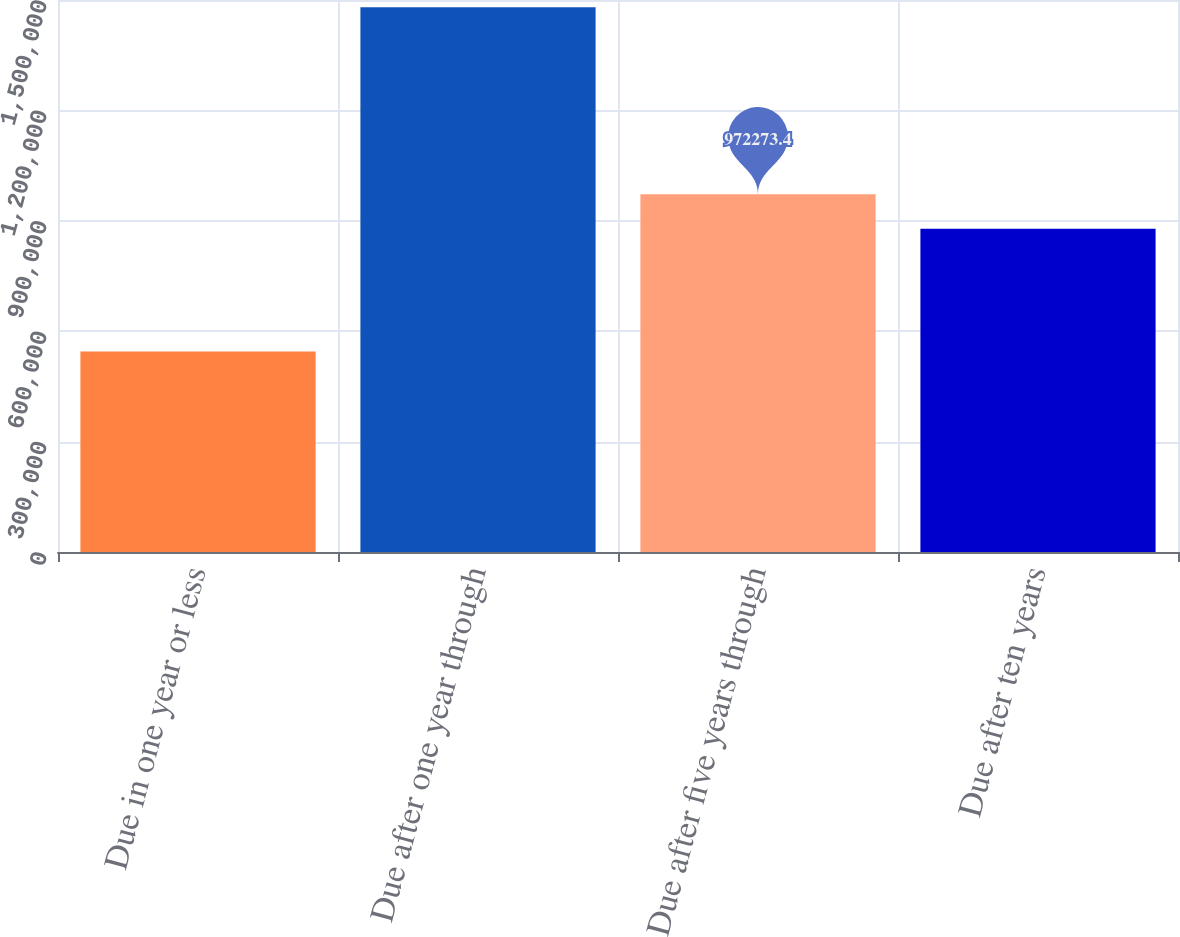Convert chart. <chart><loc_0><loc_0><loc_500><loc_500><bar_chart><fcel>Due in one year or less<fcel>Due after one year through<fcel>Due after five years through<fcel>Due after ten years<nl><fcel>544585<fcel>1.48043e+06<fcel>972273<fcel>878689<nl></chart> 